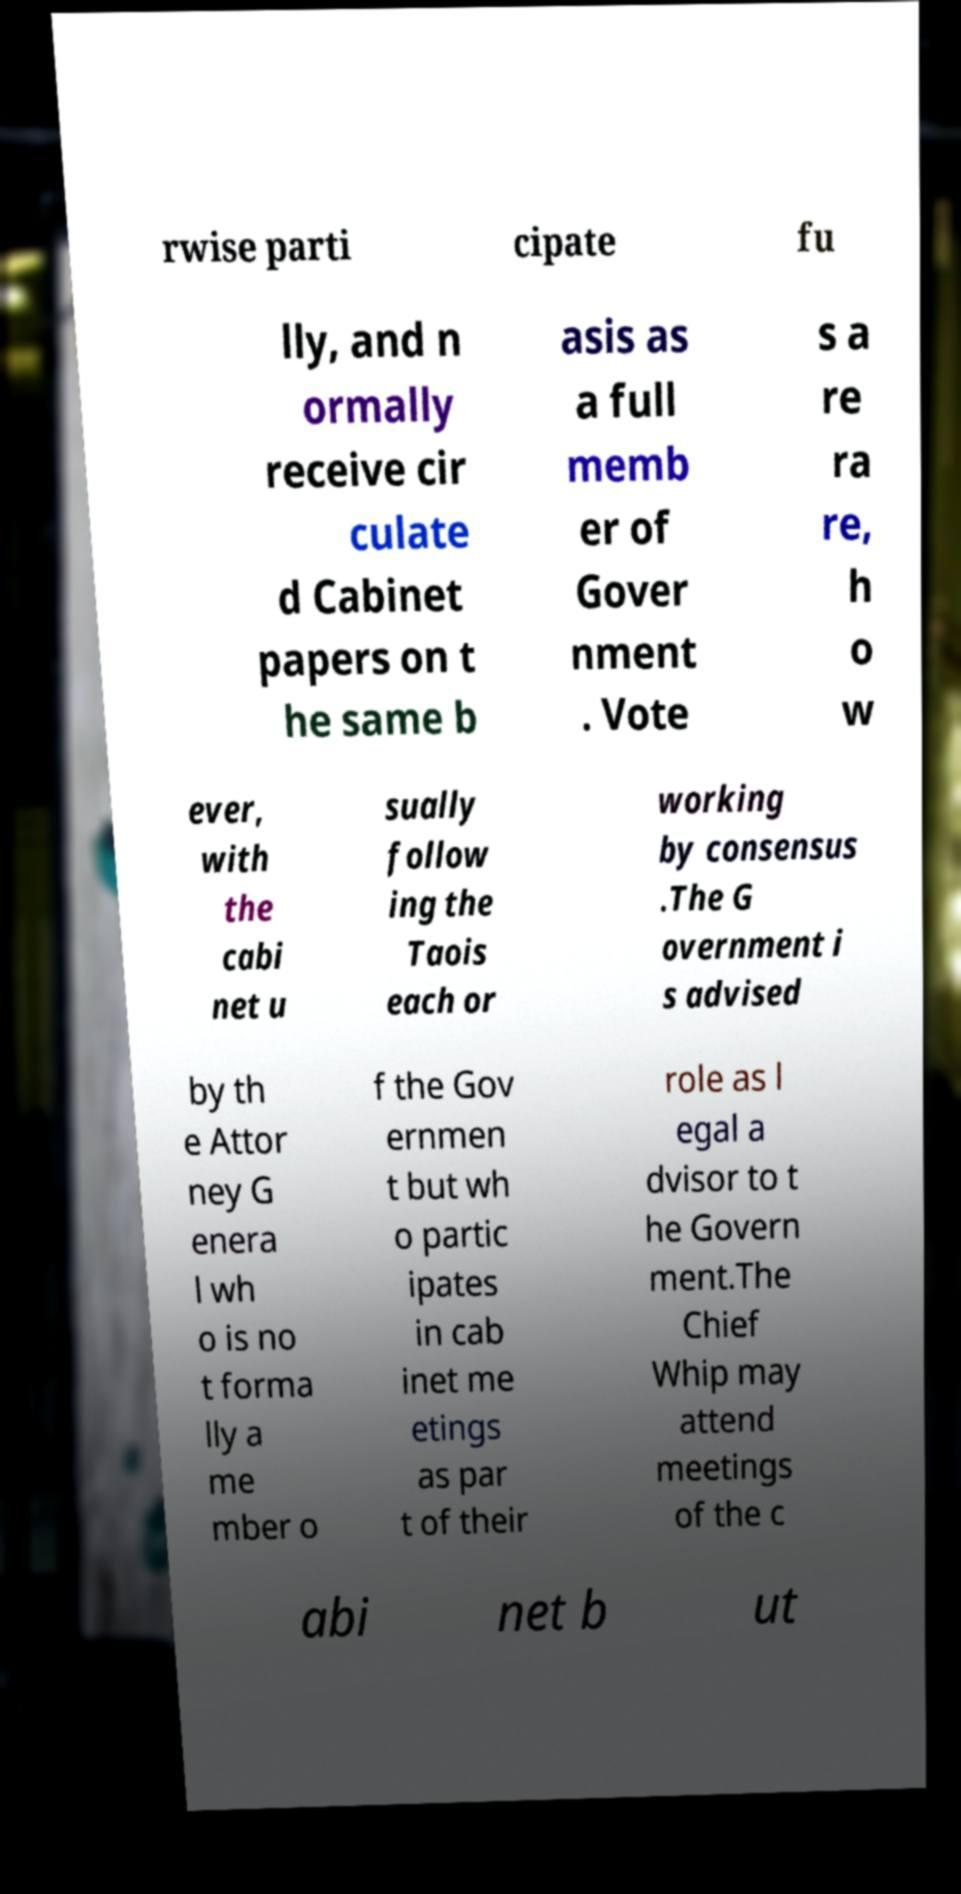Please identify and transcribe the text found in this image. rwise parti cipate fu lly, and n ormally receive cir culate d Cabinet papers on t he same b asis as a full memb er of Gover nment . Vote s a re ra re, h o w ever, with the cabi net u sually follow ing the Taois each or working by consensus .The G overnment i s advised by th e Attor ney G enera l wh o is no t forma lly a me mber o f the Gov ernmen t but wh o partic ipates in cab inet me etings as par t of their role as l egal a dvisor to t he Govern ment.The Chief Whip may attend meetings of the c abi net b ut 